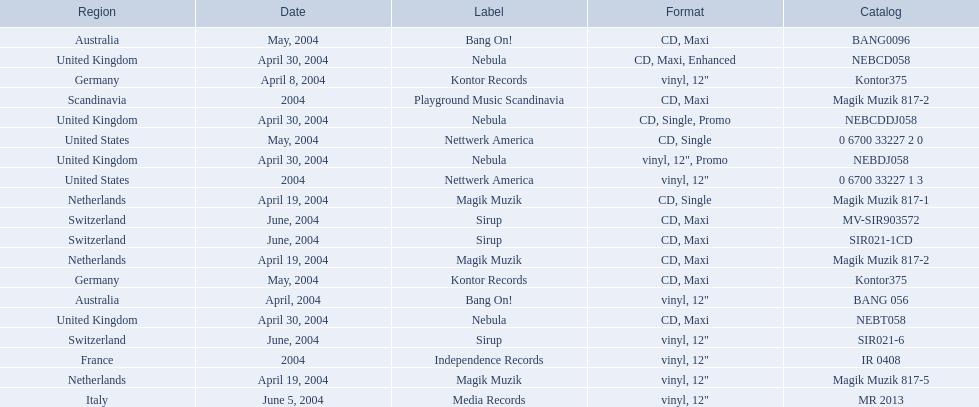What label was used by the netherlands in love comes again? Magik Muzik. What label was used in germany? Kontor Records. What label was used in france? Independence Records. 